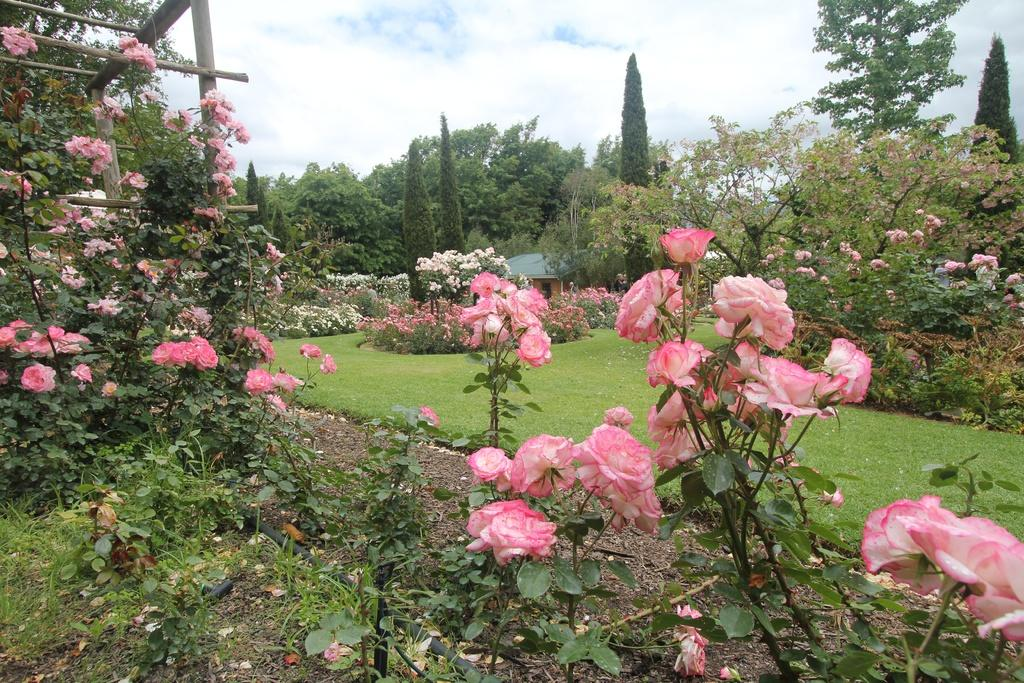What types of vegetation can be seen in the front of the image? There are flowers and plants in the front of the image. What is on the ground in the center of the image? There is grass on the ground in the center of the image. What can be seen in the background of the image? There are trees, flowers, and a cloudy sky in the background of the image. What type of meal is being prepared on the stove in the image? There is no stove or meal preparation present in the image. How many balls are visible in the image? There are no balls present in the image. 